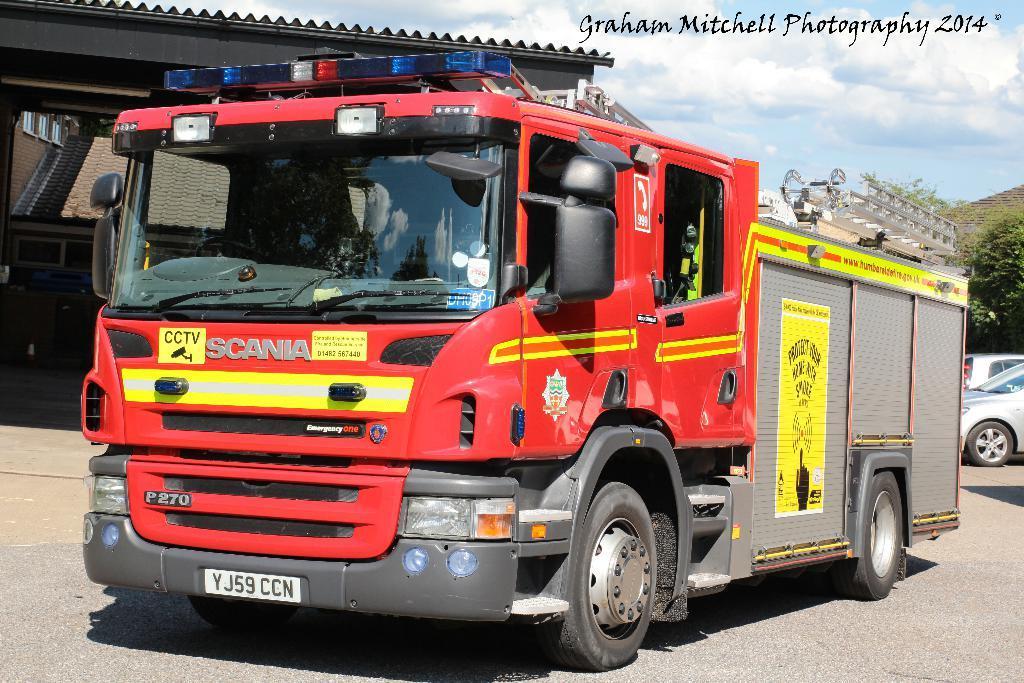In one or two sentences, can you explain what this image depicts? In this picture we can see vehicles on the road, poster, shelter, trees and in the background we can see the sky with clouds. 